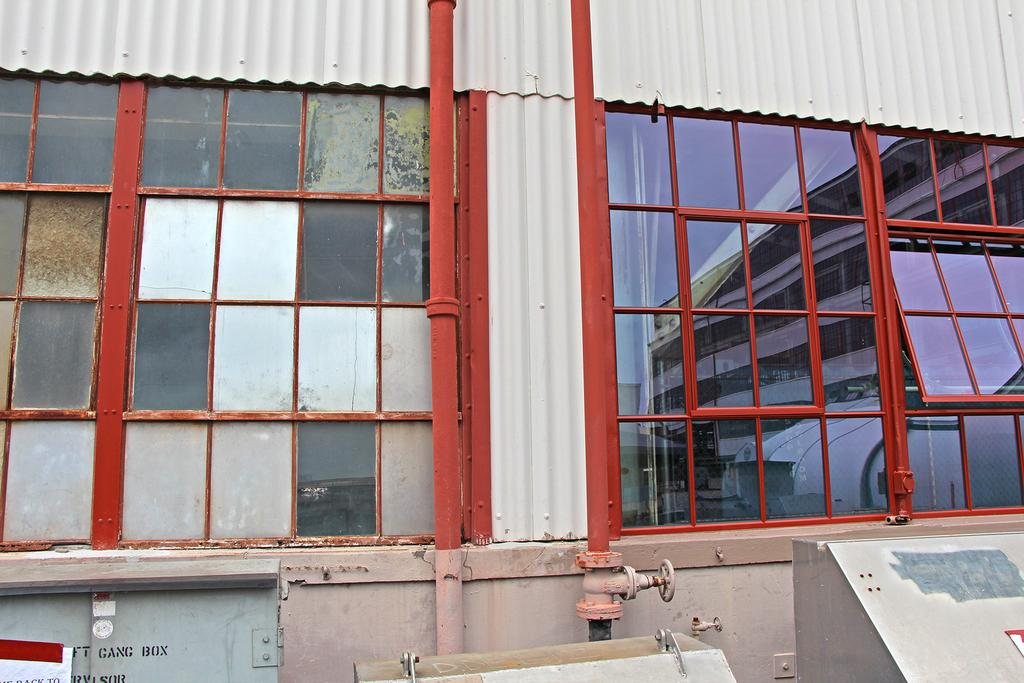What type of structure is visible in the image? There are many windows in the image, which belong to a compartment. What can be found attached to one of the rods in the image? A tap is attached to one of the rods in the image. What objects are present in front of the compartment wall? There are objects in front of the compartment wall. Can you see a receipt on the floor in the image? There is no receipt visible on the floor in the image. Are there any jewels or precious stones in the image? There is no mention of jewels or precious stones in the image. 